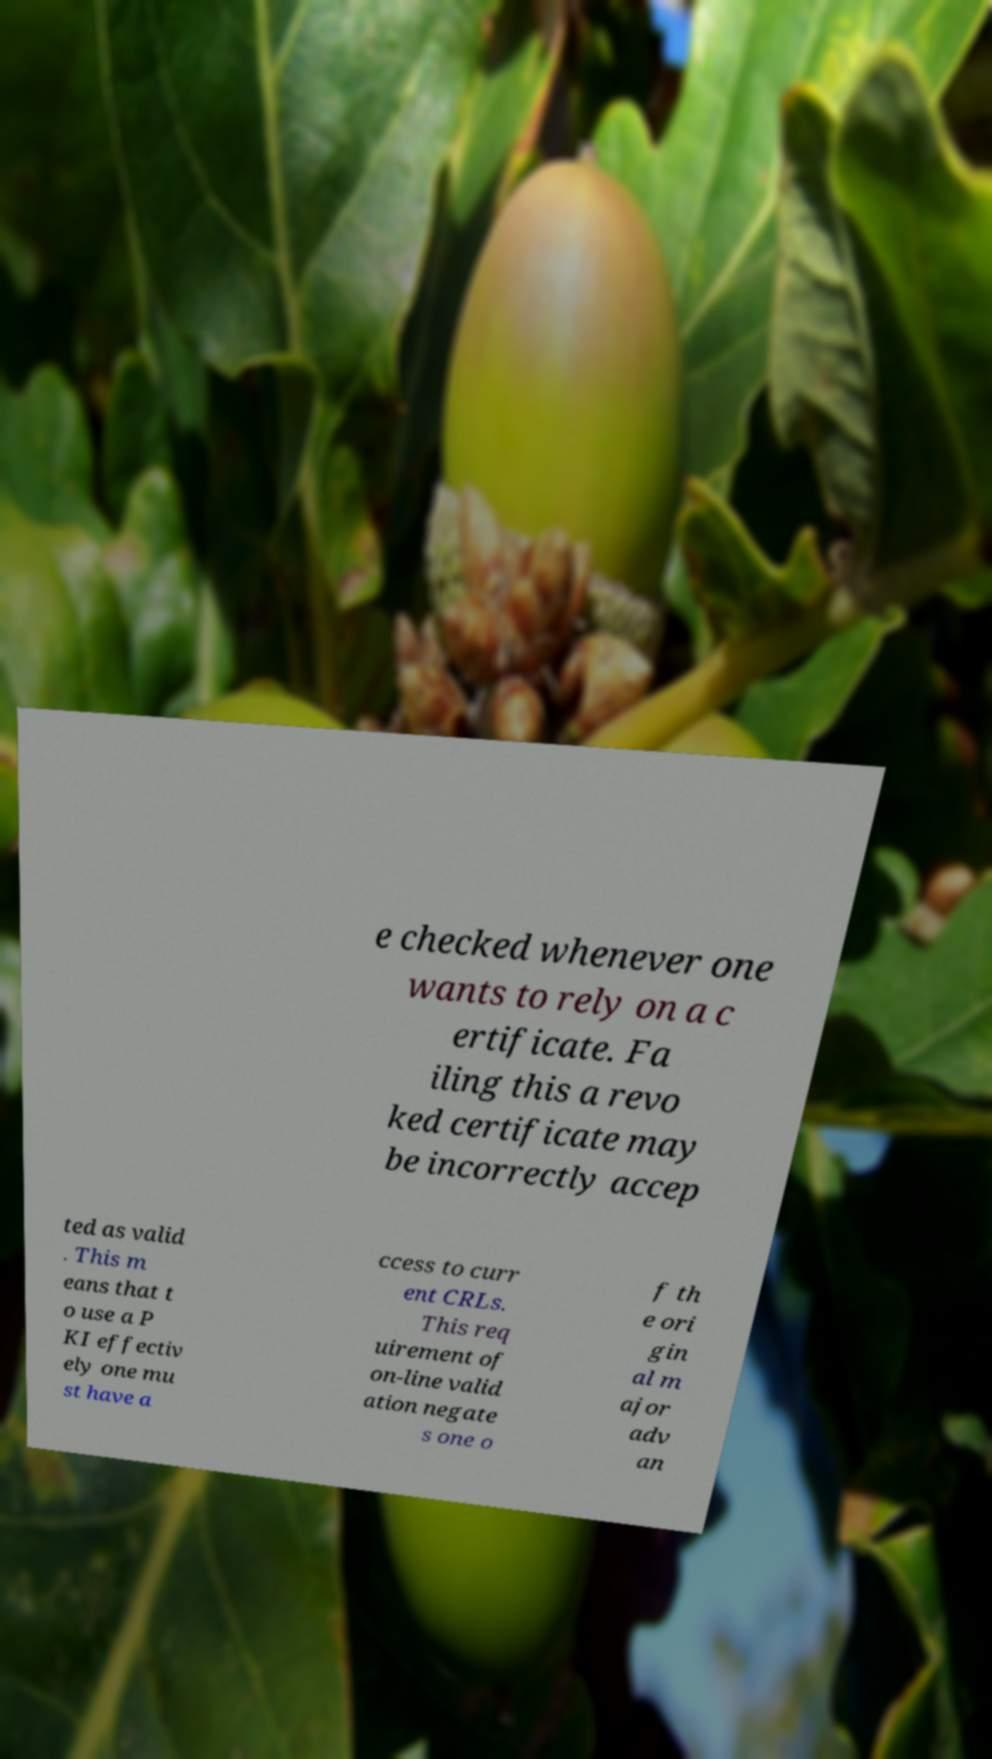There's text embedded in this image that I need extracted. Can you transcribe it verbatim? e checked whenever one wants to rely on a c ertificate. Fa iling this a revo ked certificate may be incorrectly accep ted as valid . This m eans that t o use a P KI effectiv ely one mu st have a ccess to curr ent CRLs. This req uirement of on-line valid ation negate s one o f th e ori gin al m ajor adv an 